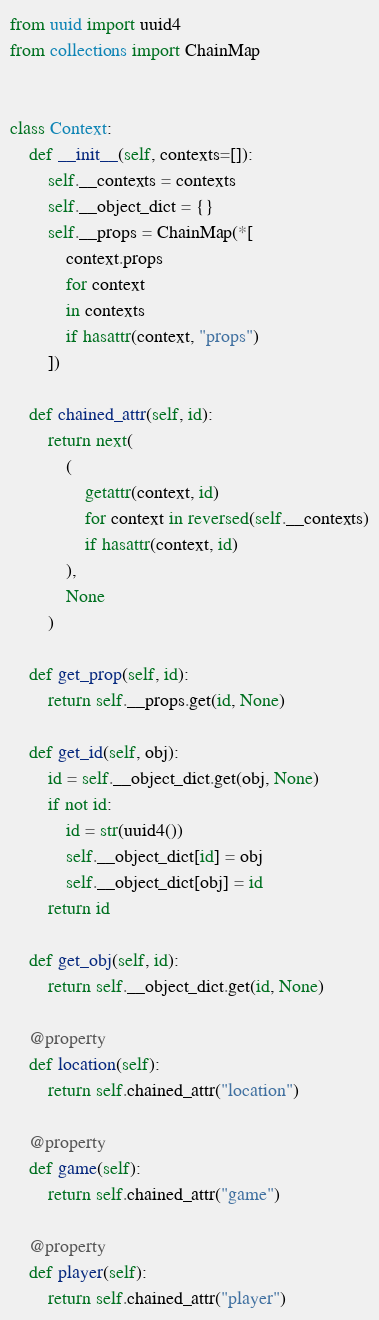<code> <loc_0><loc_0><loc_500><loc_500><_Python_>from uuid import uuid4
from collections import ChainMap


class Context:
    def __init__(self, contexts=[]):
        self.__contexts = contexts
        self.__object_dict = {}
        self.__props = ChainMap(*[
            context.props
            for context
            in contexts
            if hasattr(context, "props")
        ])

    def chained_attr(self, id):
        return next(
            (
                getattr(context, id)
                for context in reversed(self.__contexts)
                if hasattr(context, id)
            ),
            None
        )

    def get_prop(self, id):
        return self.__props.get(id, None)

    def get_id(self, obj):
        id = self.__object_dict.get(obj, None)
        if not id:
            id = str(uuid4())
            self.__object_dict[id] = obj
            self.__object_dict[obj] = id
        return id

    def get_obj(self, id):
        return self.__object_dict.get(id, None)

    @property
    def location(self):
        return self.chained_attr("location")

    @property
    def game(self):
        return self.chained_attr("game")

    @property
    def player(self):
        return self.chained_attr("player")
</code> 